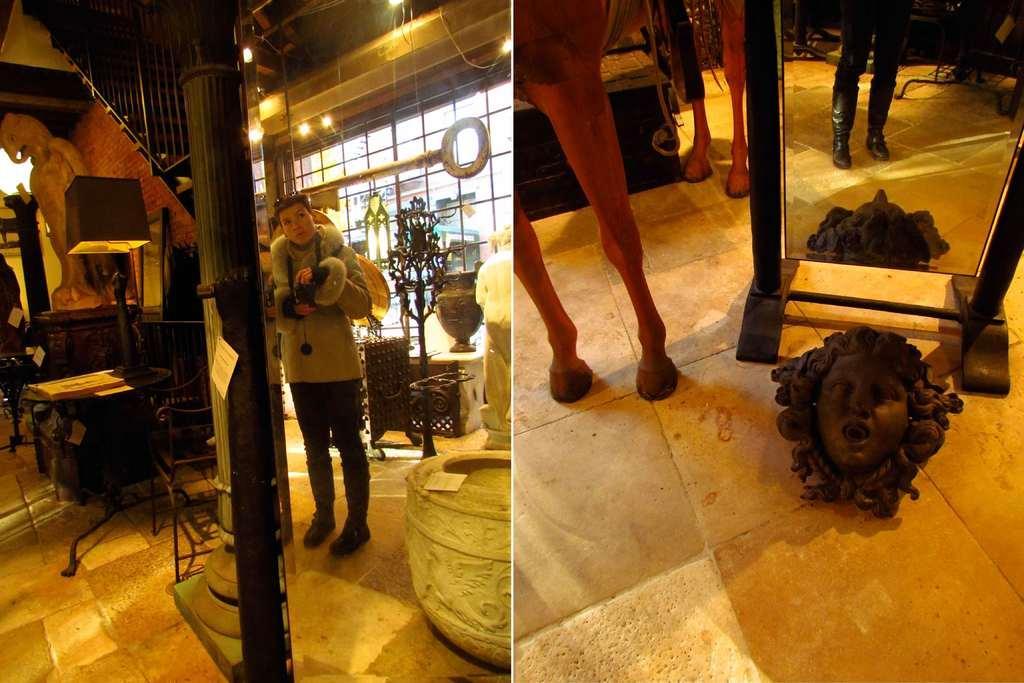Describe this image in one or two sentences. This image contains the collage of photos. Left side a person is standing on the floor, having few objects. Left side there are tables and chairs on the floor. On the table there are few objects. Left side there is a staircase. A statue is on a table. Few lights are attached to the roof. Few antique items are on the floor. Right side there is a mirror, having the reflection of a person and an idol. An animal is standing on the floor, having an idol. 